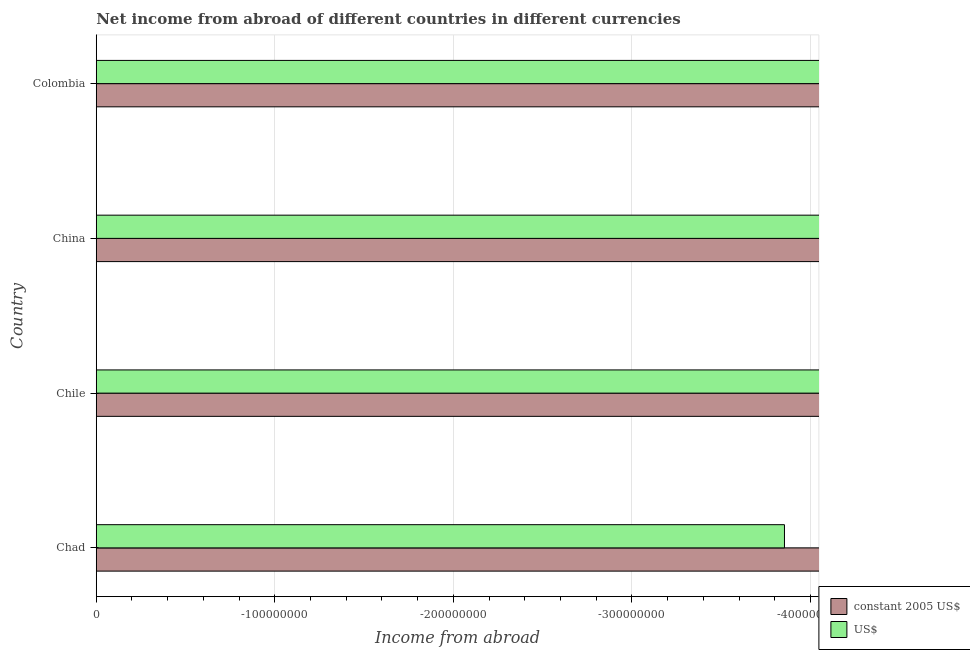Are the number of bars per tick equal to the number of legend labels?
Provide a short and direct response. No. How many bars are there on the 1st tick from the top?
Ensure brevity in your answer.  0. What is the label of the 3rd group of bars from the top?
Provide a succinct answer. Chile. In how many cases, is the number of bars for a given country not equal to the number of legend labels?
Make the answer very short. 4. What is the income from abroad in us$ in China?
Ensure brevity in your answer.  0. Across all countries, what is the minimum income from abroad in us$?
Your response must be concise. 0. What is the total income from abroad in constant 2005 us$ in the graph?
Make the answer very short. 0. What is the difference between the income from abroad in constant 2005 us$ in Chad and the income from abroad in us$ in Chile?
Your answer should be compact. 0. What is the average income from abroad in constant 2005 us$ per country?
Offer a very short reply. 0. How many bars are there?
Offer a very short reply. 0. How many countries are there in the graph?
Your response must be concise. 4. Are the values on the major ticks of X-axis written in scientific E-notation?
Your answer should be compact. No. Where does the legend appear in the graph?
Provide a short and direct response. Bottom right. How are the legend labels stacked?
Your response must be concise. Vertical. What is the title of the graph?
Give a very brief answer. Net income from abroad of different countries in different currencies. What is the label or title of the X-axis?
Your response must be concise. Income from abroad. What is the label or title of the Y-axis?
Your answer should be very brief. Country. What is the Income from abroad in constant 2005 US$ in Chad?
Make the answer very short. 0. What is the Income from abroad in constant 2005 US$ in China?
Keep it short and to the point. 0. What is the Income from abroad of constant 2005 US$ in Colombia?
Offer a very short reply. 0. What is the total Income from abroad of constant 2005 US$ in the graph?
Offer a very short reply. 0. What is the average Income from abroad in US$ per country?
Your answer should be compact. 0. 